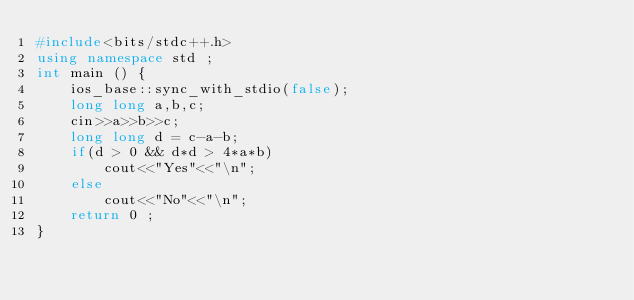Convert code to text. <code><loc_0><loc_0><loc_500><loc_500><_C++_>#include<bits/stdc++.h>
using namespace std ; 
int main () { 
    ios_base::sync_with_stdio(false);
    long long a,b,c;
    cin>>a>>b>>c;
    long long d = c-a-b;
    if(d > 0 && d*d > 4*a*b) 
        cout<<"Yes"<<"\n";
    else  
        cout<<"No"<<"\n";
    return 0 ; 
}</code> 